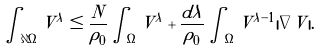<formula> <loc_0><loc_0><loc_500><loc_500>\int _ { \partial \Omega } V ^ { \lambda } \leq \frac { N } { \rho _ { 0 } } \int _ { \Omega } V ^ { \lambda } + \frac { d \lambda } { \rho _ { 0 } } \int _ { \Omega } V ^ { \lambda - 1 } | \nabla V | .</formula> 